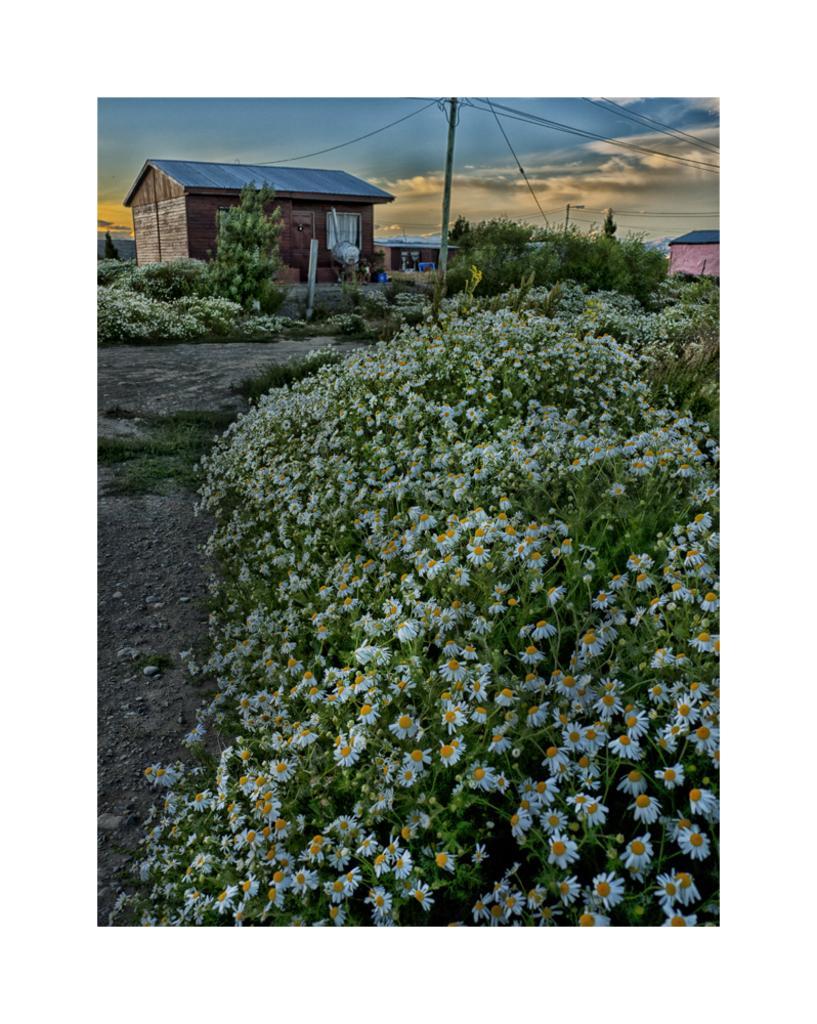Could you give a brief overview of what you see in this image? In this image in the front there are flowers. In the background there are houses, poles, plants and the sky is cloudy. 